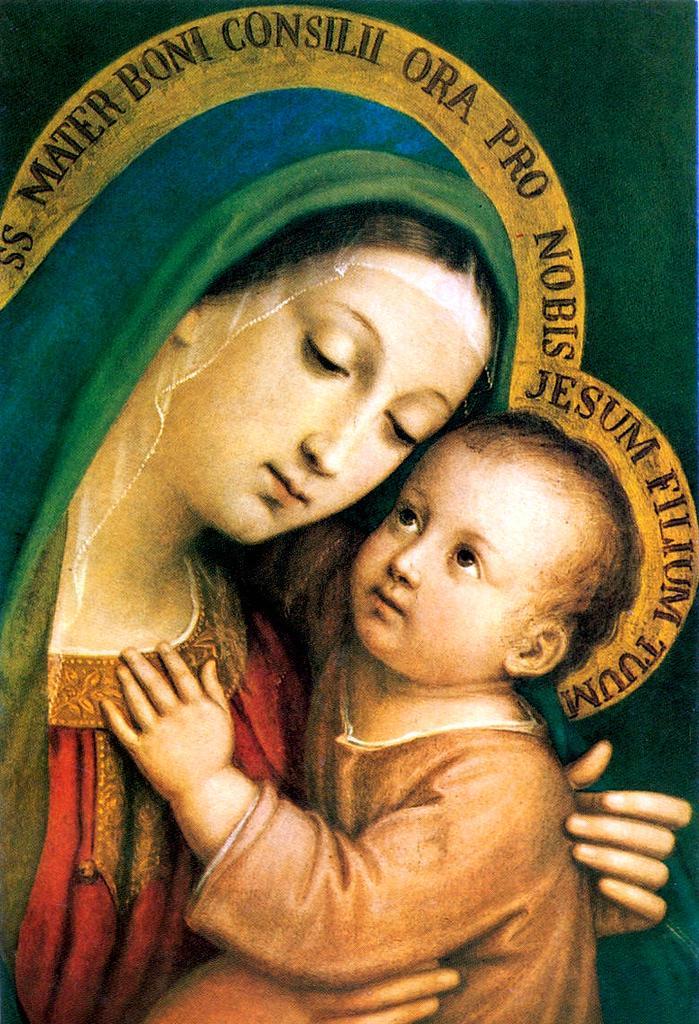Can you describe this image briefly? In this image there are pictures of a woman and a kid. The woman is holding the kid. There is text around them. 